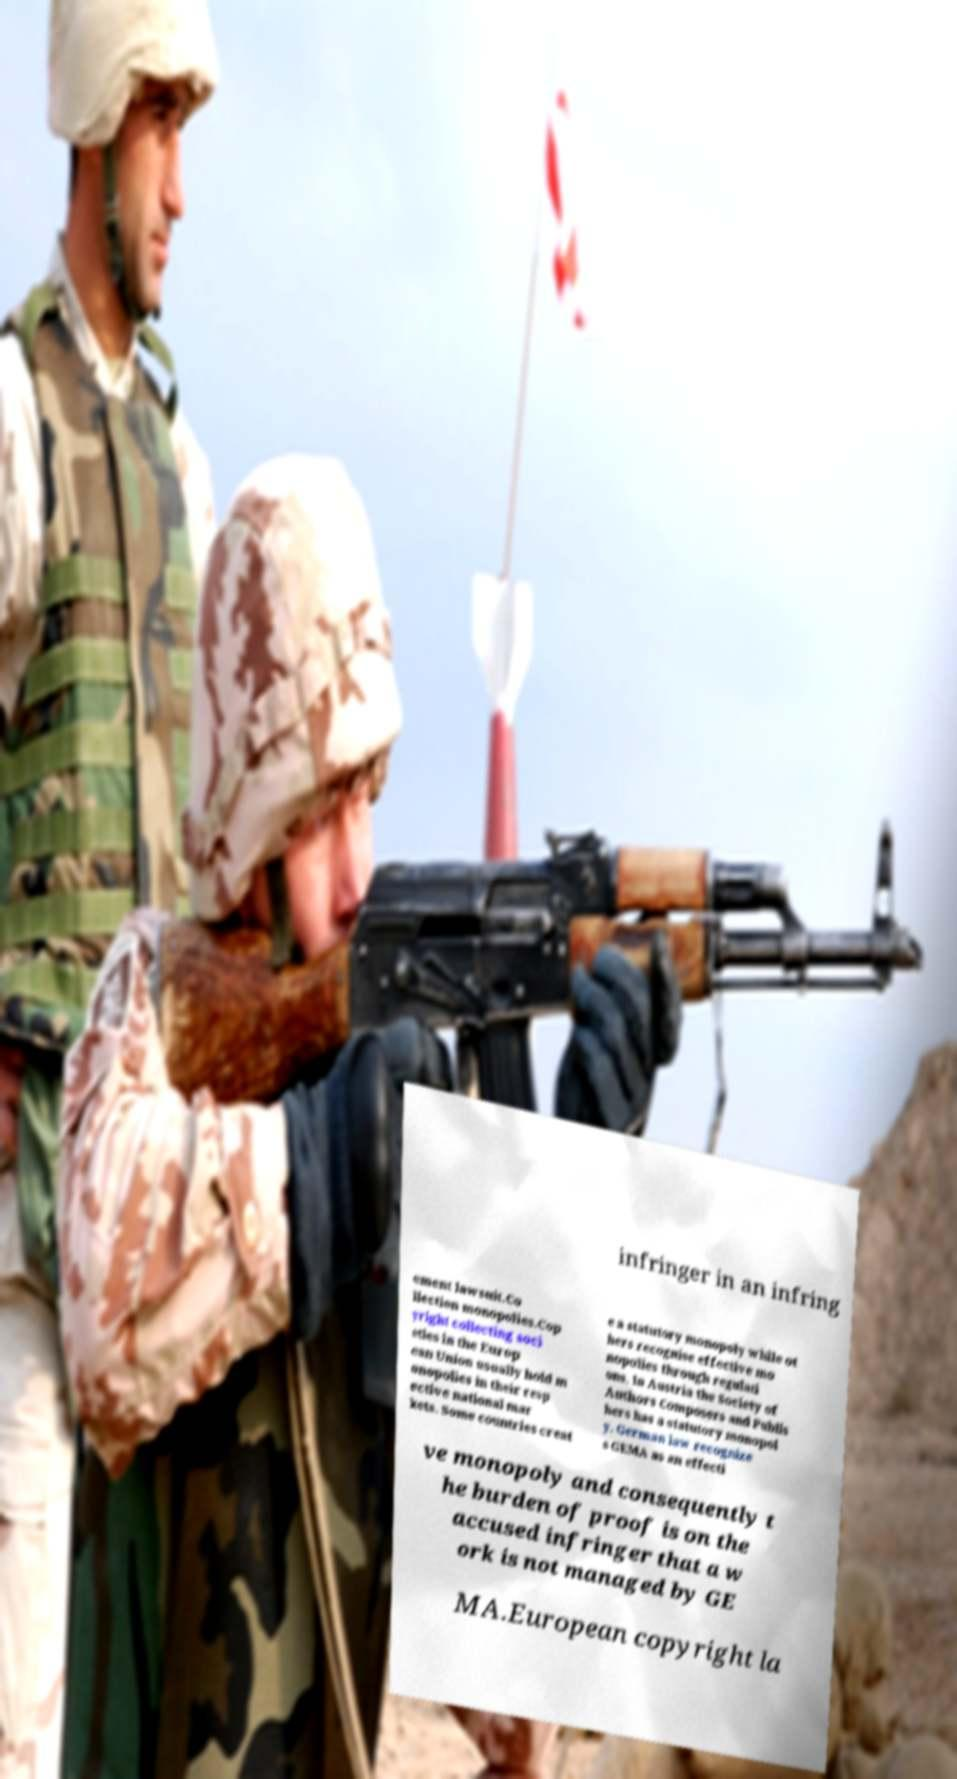Please read and relay the text visible in this image. What does it say? infringer in an infring ement lawsuit.Co llection monopolies.Cop yright collecting soci eties in the Europ ean Union usually hold m onopolies in their resp ective national mar kets. Some countries creat e a statutory monopoly while ot hers recognise effective mo nopolies through regulati ons. In Austria the Society of Authors Composers and Publis hers has a statutory monopol y. German law recognize s GEMA as an effecti ve monopoly and consequently t he burden of proof is on the accused infringer that a w ork is not managed by GE MA.European copyright la 